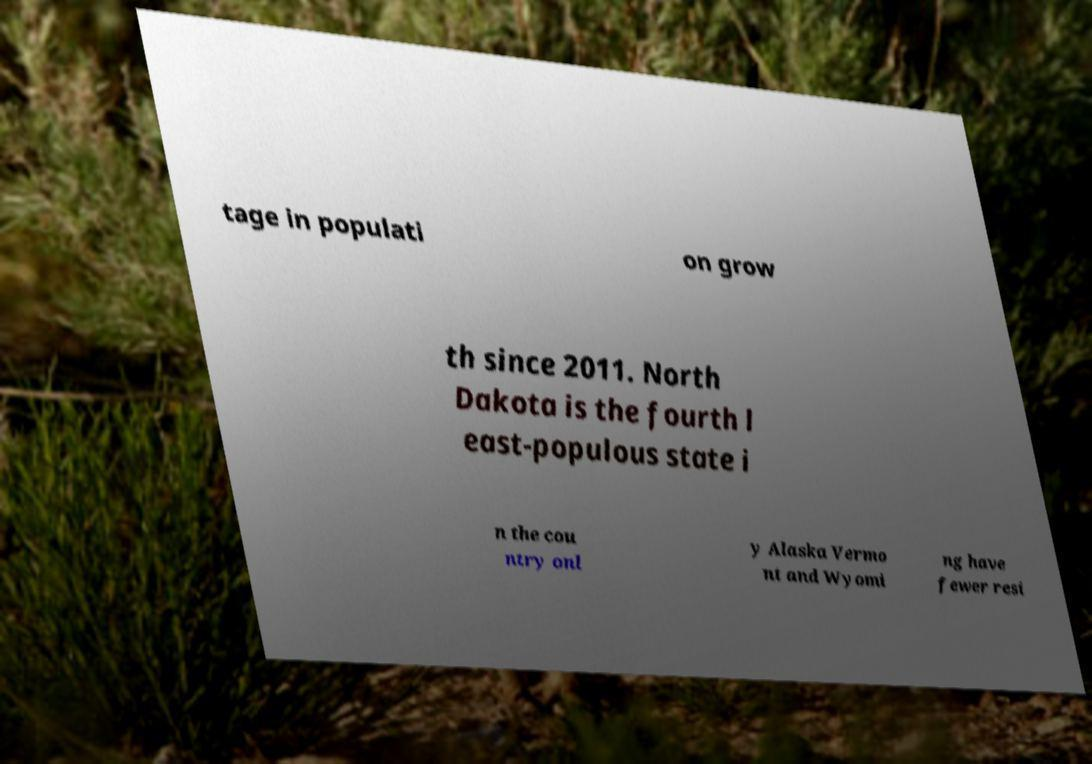Please identify and transcribe the text found in this image. tage in populati on grow th since 2011. North Dakota is the fourth l east-populous state i n the cou ntry onl y Alaska Vermo nt and Wyomi ng have fewer resi 